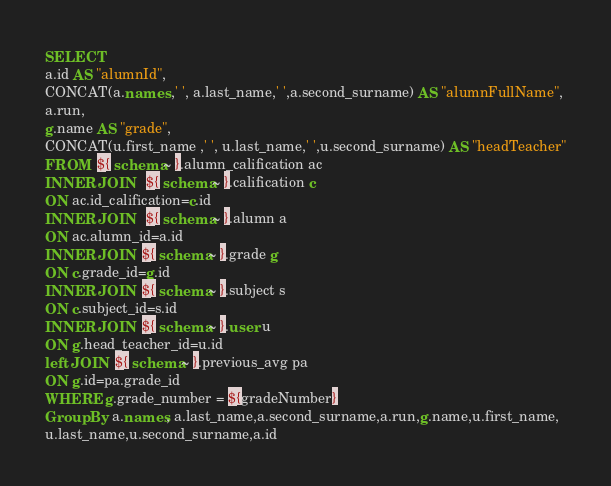<code> <loc_0><loc_0><loc_500><loc_500><_SQL_>SELECT
a.id AS "alumnId",
CONCAT(a.names ,' ', a.last_name,' ',a.second_surname) AS "alumnFullName",
a.run,
g.name AS "grade",
CONCAT(u.first_name ,' ', u.last_name,' ',u.second_surname) AS "headTeacher"
FROM  ${ schema~ }.alumn_calification ac
INNER JOIN   ${ schema~ }.calification c
ON ac.id_calification=c.id
INNER JOIN   ${ schema~ }.alumn a
ON ac.alumn_id=a.id
INNER JOIN  ${ schema~ }.grade g
ON c.grade_id=g.id
INNER JOIN  ${ schema~ }.subject s
ON c.subject_id=s.id
INNER JOIN  ${ schema~ }.user u
ON g.head_teacher_id=u.id
left JOIN  ${ schema~ }.previous_avg pa
ON g.id=pa.grade_id
WHERE g.grade_number = ${gradeNumber}
Group By a.names, a.last_name,a.second_surname,a.run,g.name,u.first_name,
u.last_name,u.second_surname,a.id




</code> 